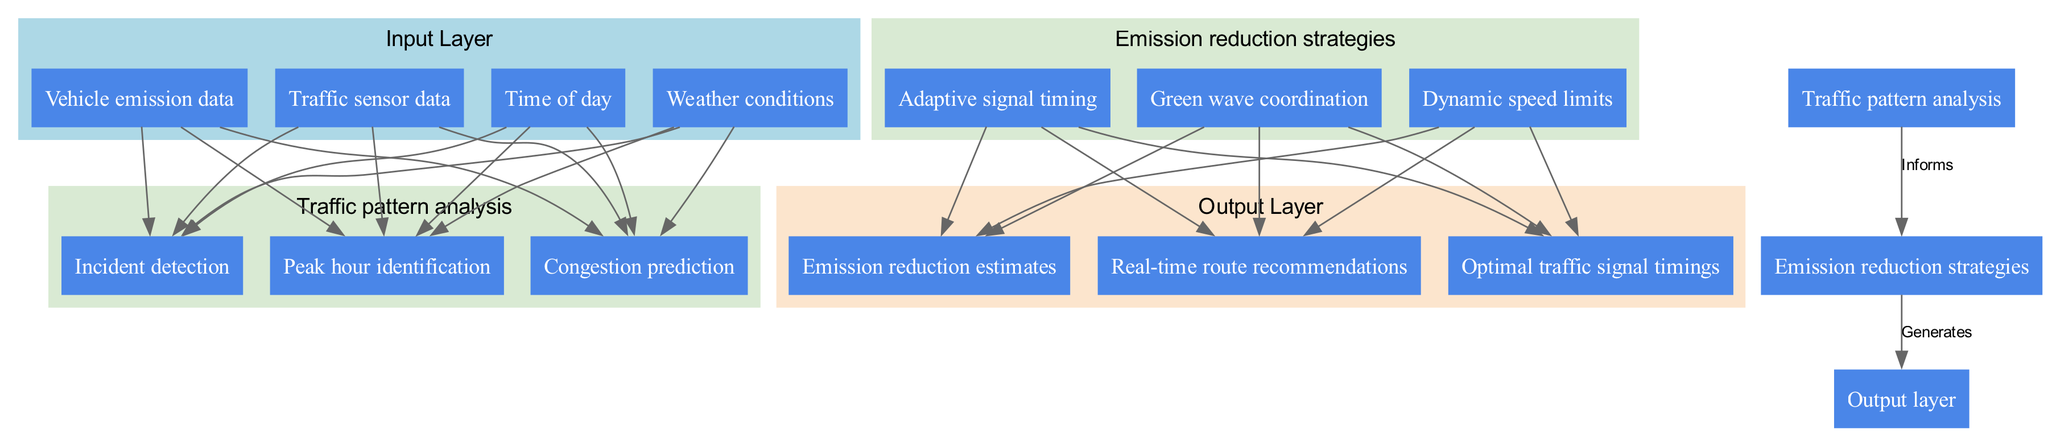What are the components of the input layer? The input layer consists of four components: Traffic sensor data, Vehicle emission data, Weather conditions, and Time of day. These are visual nodes in the diagram under the input layer section.
Answer: Traffic sensor data, Vehicle emission data, Weather conditions, Time of day How many nodes are in the hidden layer for Traffic pattern analysis? The hidden layer named Traffic pattern analysis contains three nodes: Congestion prediction, Peak hour identification, and Incident detection, as indicated in the diagram.
Answer: 3 What is the main output of the neural network architecture? The output layer generates three main outputs: Optimal traffic signal timings, Real-time route recommendations, and Emission reduction estimates, as shown in the diagram.
Answer: Optimal traffic signal timings, Real-time route recommendations, Emission reduction estimates Which hidden layer informs the strategies in the second hidden layer? The diagram specifies that the hidden layer for Traffic pattern analysis informs the Emission reduction strategies by showing a directed edge labeled "Informs" between these two nodes.
Answer: Traffic pattern analysis What is the relationship between the emission reduction strategies and the output layer? The emission reduction strategies generate the outputs as indicated in the diagram, which shows a directed edge from this hidden layer to the output layer labeled "Generates."
Answer: Generates How many connections are there from the input layer to the first hidden layer? The diagram shows that there are four input nodes that connect to three nodes in the first hidden layer, resulting in a total of twelve connections (4 inputs X 3 nodes). However, since the number is not about unique connections and not directly shown, referencing the nodes indicates there are three unique nodes influenced by all four input nodes.
Answer: 12 connections What are the nodes in the second hidden layer? The second hidden layer is named Emission reduction strategies and includes three nodes: Green wave coordination, Dynamic speed limits, and Adaptive signal timing, which are visually represented in the diagram.
Answer: Green wave coordination, Dynamic speed limits, Adaptive signal timing Which hidden layer contributes to optimal traffic signal timings? According to the diagram's flow, the output layer for Optimal traffic signal timings is influenced by the Emission reduction strategies hidden layer, suggesting it’s a collaborative output from it. Thus, both hidden layers play a role in determining it, but primarily the second.
Answer: Emission reduction strategies How many layers are there in total in the neural network architecture? The diagram presents three distinct layers: the input layer, two hidden layers, and the output layer, resulting in a total of four layers.
Answer: 4 layers 